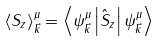<formula> <loc_0><loc_0><loc_500><loc_500>\left \langle S _ { z } \right \rangle _ { \vec { k } } ^ { \mu } = \left \langle \psi _ { \vec { k } } ^ { \mu } \left | \hat { S } _ { z } \right | \psi _ { \vec { k } } ^ { \mu } \right \rangle</formula> 